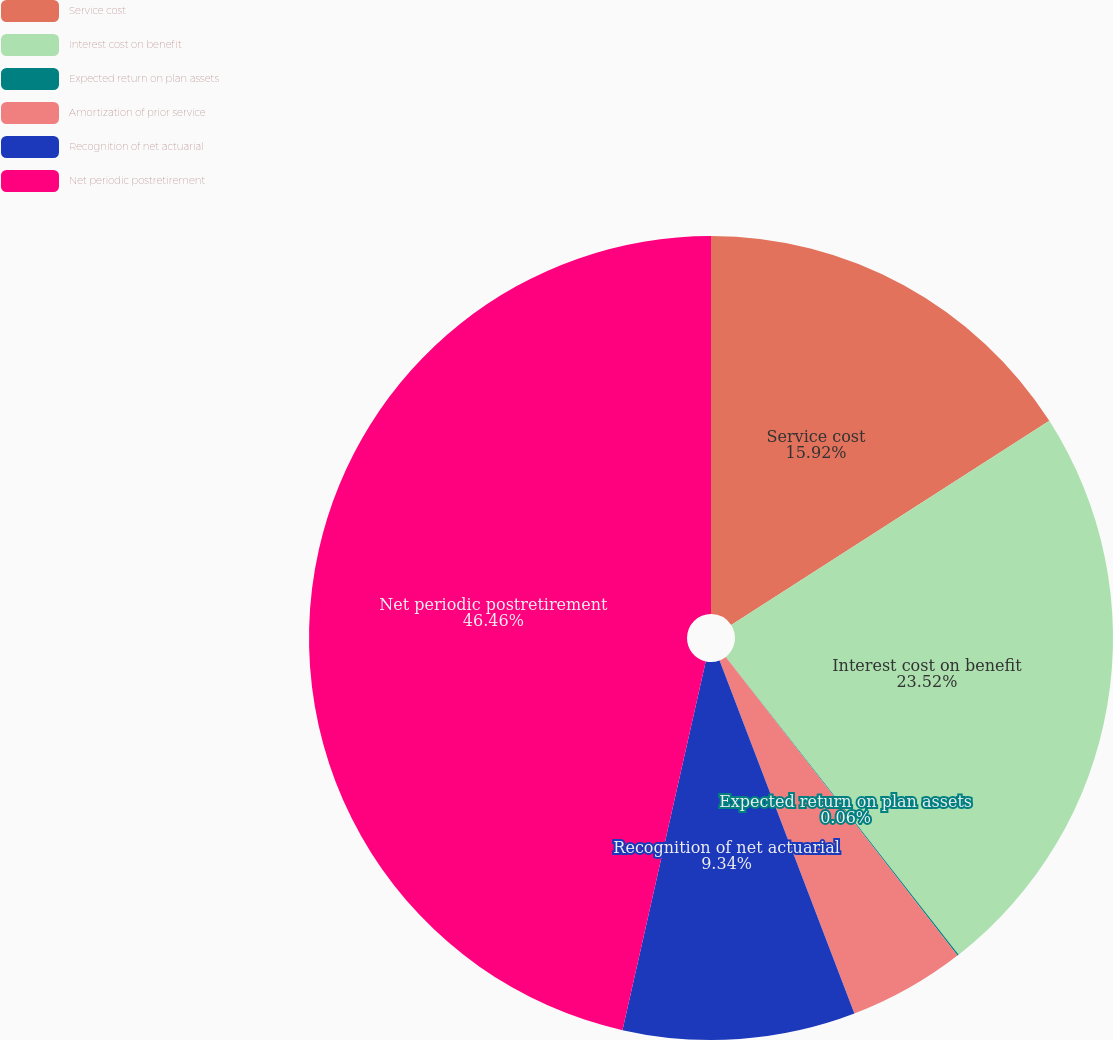Convert chart to OTSL. <chart><loc_0><loc_0><loc_500><loc_500><pie_chart><fcel>Service cost<fcel>Interest cost on benefit<fcel>Expected return on plan assets<fcel>Amortization of prior service<fcel>Recognition of net actuarial<fcel>Net periodic postretirement<nl><fcel>15.92%<fcel>23.52%<fcel>0.06%<fcel>4.7%<fcel>9.34%<fcel>46.47%<nl></chart> 